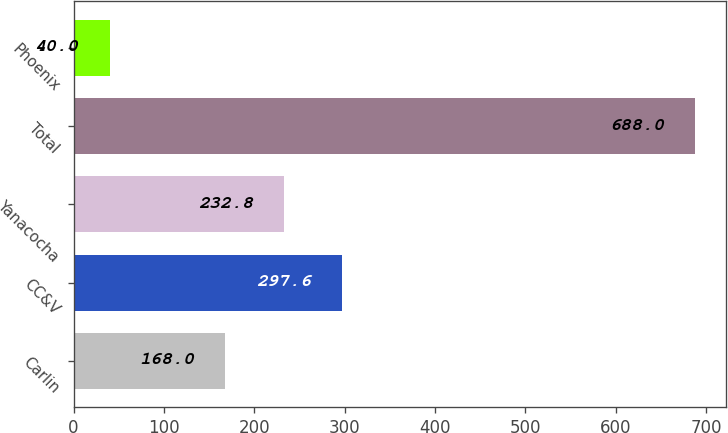Convert chart to OTSL. <chart><loc_0><loc_0><loc_500><loc_500><bar_chart><fcel>Carlin<fcel>CC&V<fcel>Yanacocha<fcel>Total<fcel>Phoenix<nl><fcel>168<fcel>297.6<fcel>232.8<fcel>688<fcel>40<nl></chart> 